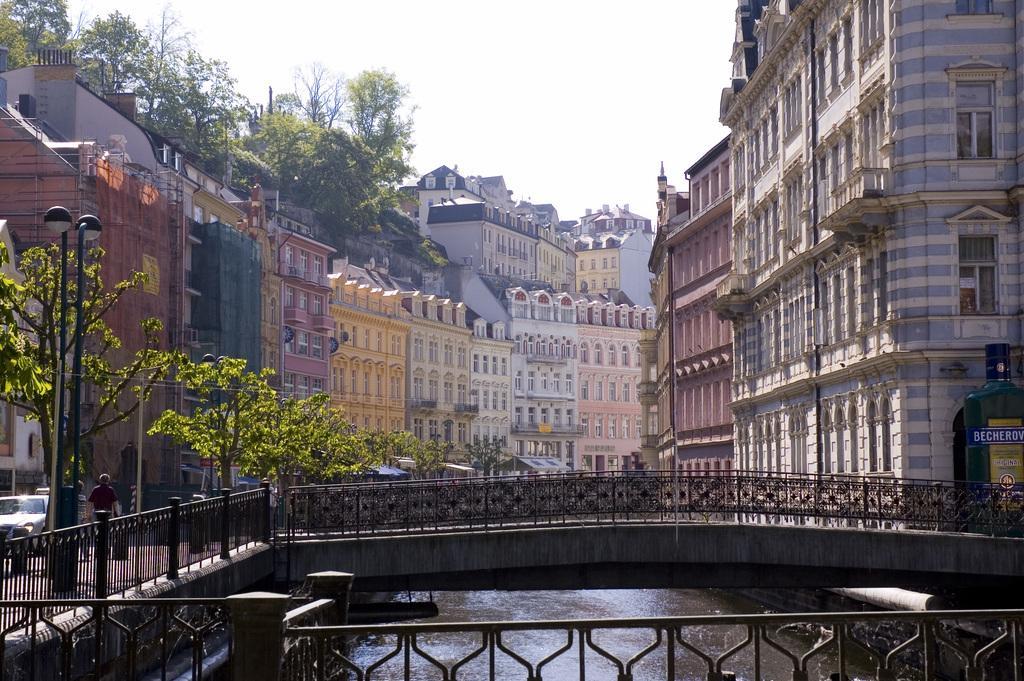Could you give a brief overview of what you see in this image? In this picture there is a bridge which has fence on either sides of it and there is water below it and there are buildings on either sides of it and there are trees in the left corner. 